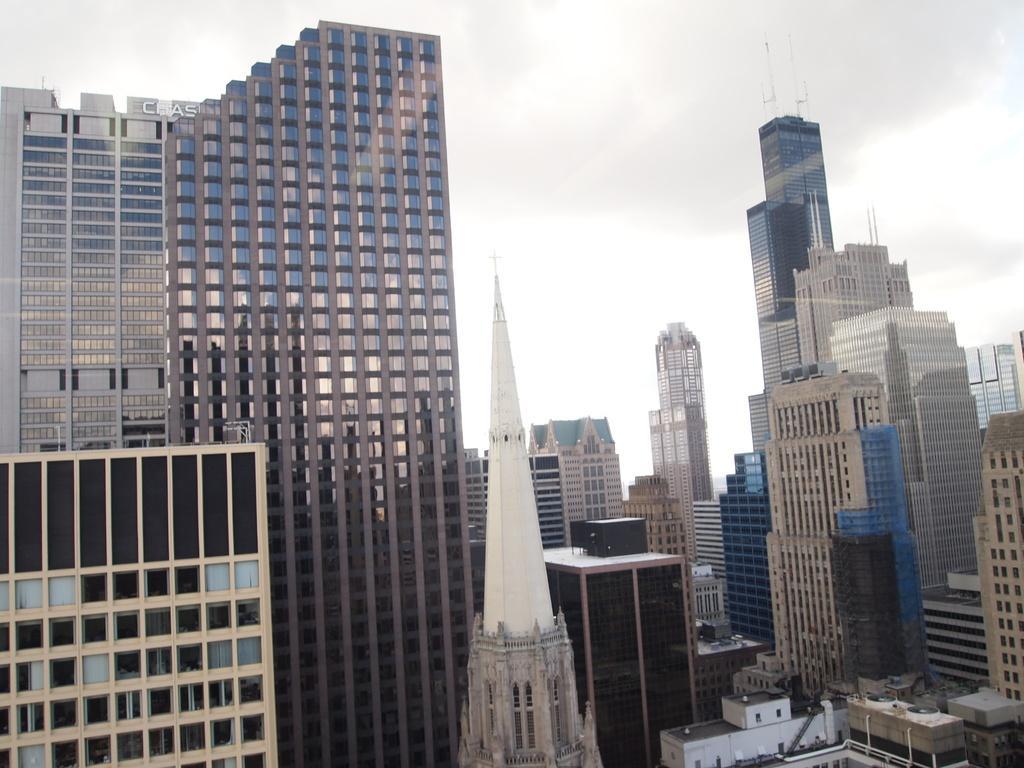Can you describe this image briefly? This image consists of so many buildings. There is sky at the top. 